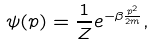<formula> <loc_0><loc_0><loc_500><loc_500>\psi ( { p } ) = \frac { 1 } { Z } e ^ { - \beta \frac { { p } ^ { 2 } } { 2 m } } ,</formula> 